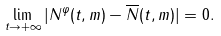Convert formula to latex. <formula><loc_0><loc_0><loc_500><loc_500>\lim _ { t \to + \infty } | N ^ { \varphi } ( t , m ) - \overline { N } ( t , m ) | = 0 .</formula> 